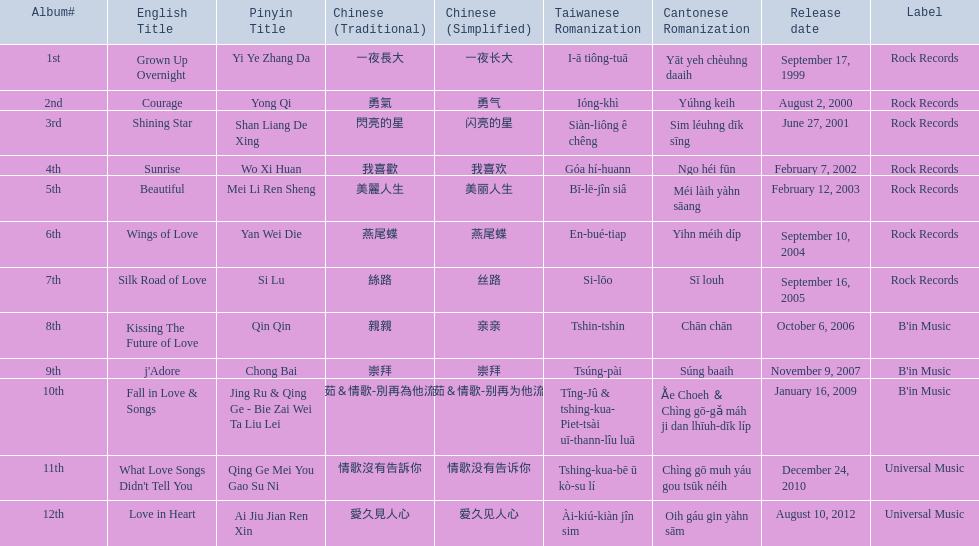Was the album beautiful released before the album love in heart? Yes. 